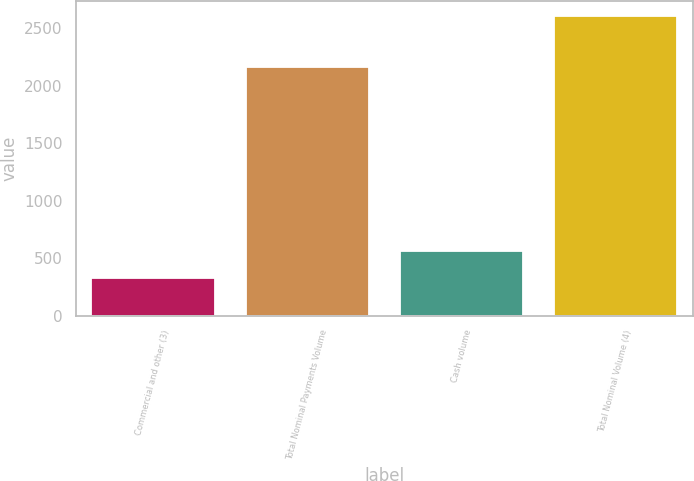<chart> <loc_0><loc_0><loc_500><loc_500><bar_chart><fcel>Commercial and other (3)<fcel>Total Nominal Payments Volume<fcel>Cash volume<fcel>Total Nominal Volume (4)<nl><fcel>331<fcel>2166<fcel>559.1<fcel>2612<nl></chart> 